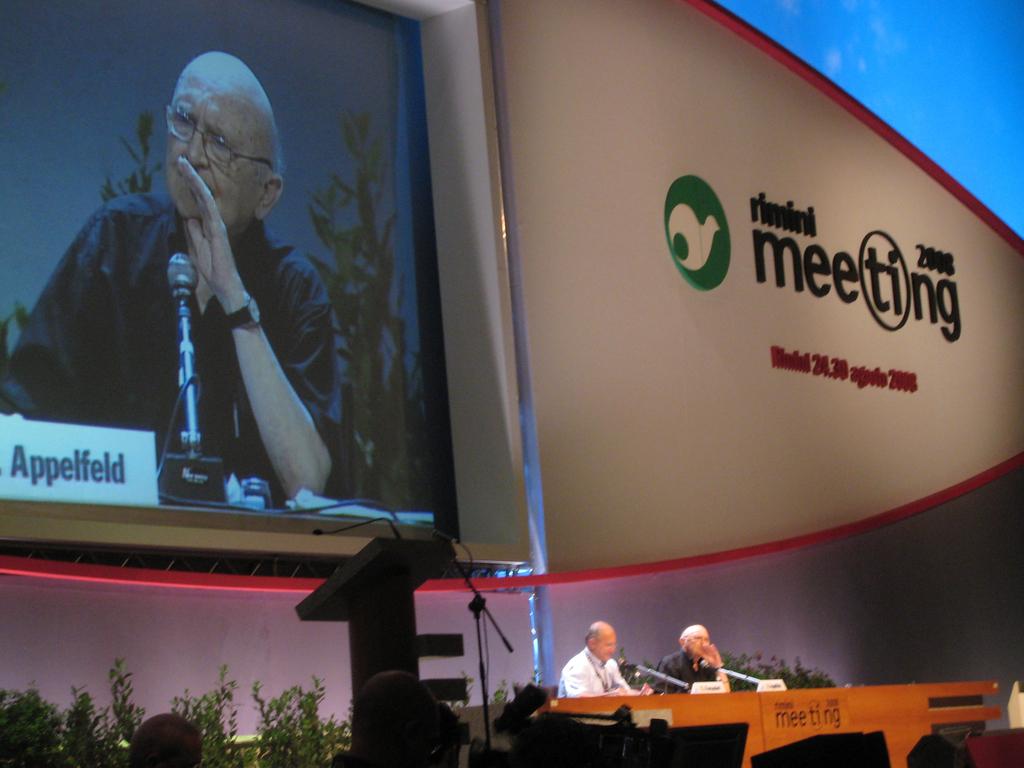What is this meeting for?
Give a very brief answer. Unanswerable. 